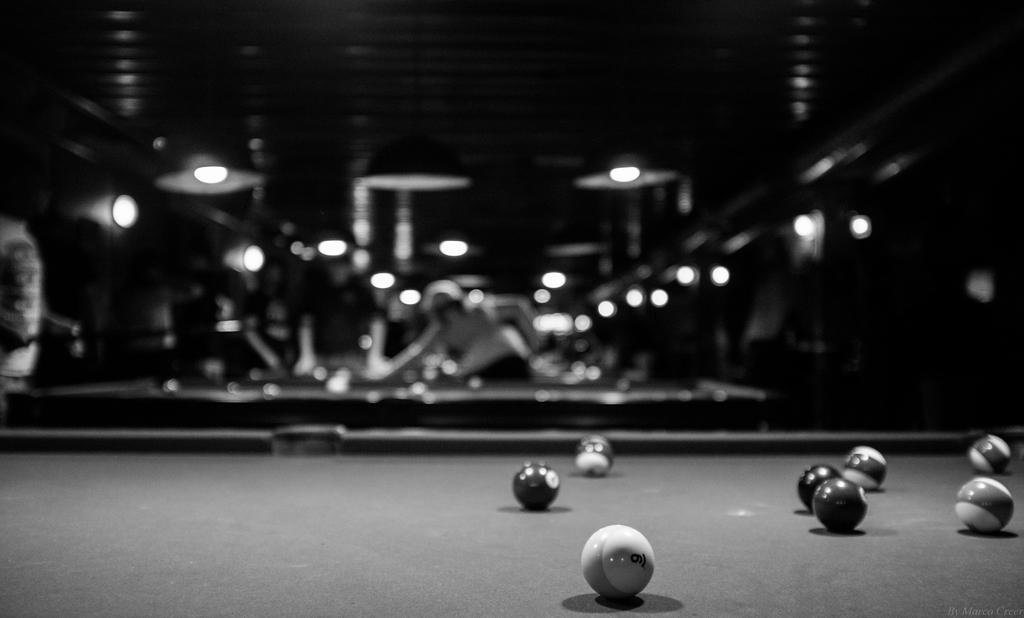What type of location is depicted in the image? The image is of the inside of a location. What is the main object in the foreground of the image? There is a billiard table in the foreground. What is placed on the billiard table? Billiard balls are placed on the top of the table. Can you describe the background of the image? There is a person visible in the background, and lights are present as well. What type of pipe is being used by the person in the background? There is no pipe visible in the image; only a person and lights are present in the background. 